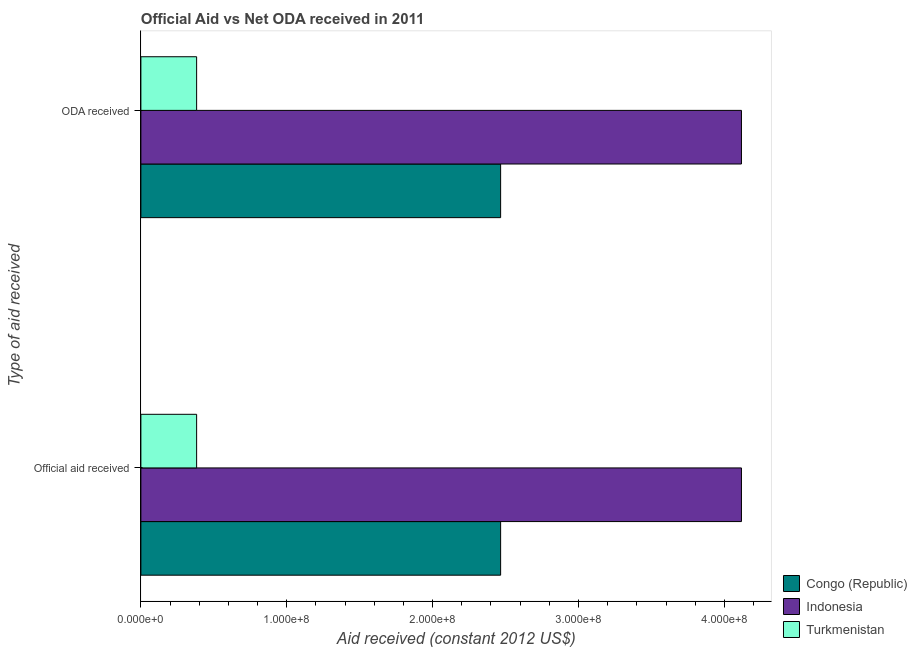Are the number of bars on each tick of the Y-axis equal?
Provide a succinct answer. Yes. How many bars are there on the 2nd tick from the top?
Your response must be concise. 3. What is the label of the 1st group of bars from the top?
Provide a short and direct response. ODA received. What is the official aid received in Turkmenistan?
Provide a succinct answer. 3.82e+07. Across all countries, what is the maximum official aid received?
Make the answer very short. 4.12e+08. Across all countries, what is the minimum official aid received?
Provide a short and direct response. 3.82e+07. In which country was the oda received minimum?
Keep it short and to the point. Turkmenistan. What is the total oda received in the graph?
Give a very brief answer. 6.97e+08. What is the difference between the official aid received in Turkmenistan and that in Congo (Republic)?
Your answer should be compact. -2.08e+08. What is the difference between the official aid received in Congo (Republic) and the oda received in Indonesia?
Your response must be concise. -1.65e+08. What is the average official aid received per country?
Provide a short and direct response. 2.32e+08. What is the difference between the official aid received and oda received in Indonesia?
Keep it short and to the point. 0. What is the ratio of the oda received in Congo (Republic) to that in Turkmenistan?
Offer a very short reply. 6.45. What does the 3rd bar from the top in Official aid received represents?
Your answer should be compact. Congo (Republic). What does the 3rd bar from the bottom in ODA received represents?
Offer a very short reply. Turkmenistan. Are all the bars in the graph horizontal?
Give a very brief answer. Yes. Does the graph contain grids?
Provide a short and direct response. No. How many legend labels are there?
Provide a short and direct response. 3. How are the legend labels stacked?
Offer a very short reply. Vertical. What is the title of the graph?
Keep it short and to the point. Official Aid vs Net ODA received in 2011 . What is the label or title of the X-axis?
Your answer should be very brief. Aid received (constant 2012 US$). What is the label or title of the Y-axis?
Offer a very short reply. Type of aid received. What is the Aid received (constant 2012 US$) of Congo (Republic) in Official aid received?
Your answer should be compact. 2.47e+08. What is the Aid received (constant 2012 US$) of Indonesia in Official aid received?
Ensure brevity in your answer.  4.12e+08. What is the Aid received (constant 2012 US$) in Turkmenistan in Official aid received?
Keep it short and to the point. 3.82e+07. What is the Aid received (constant 2012 US$) in Congo (Republic) in ODA received?
Your response must be concise. 2.47e+08. What is the Aid received (constant 2012 US$) of Indonesia in ODA received?
Make the answer very short. 4.12e+08. What is the Aid received (constant 2012 US$) in Turkmenistan in ODA received?
Provide a succinct answer. 3.82e+07. Across all Type of aid received, what is the maximum Aid received (constant 2012 US$) in Congo (Republic)?
Give a very brief answer. 2.47e+08. Across all Type of aid received, what is the maximum Aid received (constant 2012 US$) of Indonesia?
Give a very brief answer. 4.12e+08. Across all Type of aid received, what is the maximum Aid received (constant 2012 US$) of Turkmenistan?
Provide a succinct answer. 3.82e+07. Across all Type of aid received, what is the minimum Aid received (constant 2012 US$) of Congo (Republic)?
Your answer should be compact. 2.47e+08. Across all Type of aid received, what is the minimum Aid received (constant 2012 US$) of Indonesia?
Provide a short and direct response. 4.12e+08. Across all Type of aid received, what is the minimum Aid received (constant 2012 US$) in Turkmenistan?
Make the answer very short. 3.82e+07. What is the total Aid received (constant 2012 US$) in Congo (Republic) in the graph?
Ensure brevity in your answer.  4.93e+08. What is the total Aid received (constant 2012 US$) in Indonesia in the graph?
Offer a terse response. 8.23e+08. What is the total Aid received (constant 2012 US$) in Turkmenistan in the graph?
Give a very brief answer. 7.64e+07. What is the difference between the Aid received (constant 2012 US$) in Congo (Republic) in Official aid received and the Aid received (constant 2012 US$) in Indonesia in ODA received?
Offer a very short reply. -1.65e+08. What is the difference between the Aid received (constant 2012 US$) in Congo (Republic) in Official aid received and the Aid received (constant 2012 US$) in Turkmenistan in ODA received?
Give a very brief answer. 2.08e+08. What is the difference between the Aid received (constant 2012 US$) of Indonesia in Official aid received and the Aid received (constant 2012 US$) of Turkmenistan in ODA received?
Keep it short and to the point. 3.74e+08. What is the average Aid received (constant 2012 US$) of Congo (Republic) per Type of aid received?
Your answer should be compact. 2.47e+08. What is the average Aid received (constant 2012 US$) in Indonesia per Type of aid received?
Give a very brief answer. 4.12e+08. What is the average Aid received (constant 2012 US$) in Turkmenistan per Type of aid received?
Your answer should be compact. 3.82e+07. What is the difference between the Aid received (constant 2012 US$) of Congo (Republic) and Aid received (constant 2012 US$) of Indonesia in Official aid received?
Provide a succinct answer. -1.65e+08. What is the difference between the Aid received (constant 2012 US$) in Congo (Republic) and Aid received (constant 2012 US$) in Turkmenistan in Official aid received?
Your answer should be compact. 2.08e+08. What is the difference between the Aid received (constant 2012 US$) in Indonesia and Aid received (constant 2012 US$) in Turkmenistan in Official aid received?
Keep it short and to the point. 3.74e+08. What is the difference between the Aid received (constant 2012 US$) of Congo (Republic) and Aid received (constant 2012 US$) of Indonesia in ODA received?
Provide a short and direct response. -1.65e+08. What is the difference between the Aid received (constant 2012 US$) of Congo (Republic) and Aid received (constant 2012 US$) of Turkmenistan in ODA received?
Offer a terse response. 2.08e+08. What is the difference between the Aid received (constant 2012 US$) of Indonesia and Aid received (constant 2012 US$) of Turkmenistan in ODA received?
Give a very brief answer. 3.74e+08. What is the ratio of the Aid received (constant 2012 US$) of Indonesia in Official aid received to that in ODA received?
Offer a very short reply. 1. What is the ratio of the Aid received (constant 2012 US$) of Turkmenistan in Official aid received to that in ODA received?
Give a very brief answer. 1. What is the difference between the highest and the lowest Aid received (constant 2012 US$) in Turkmenistan?
Your response must be concise. 0. 